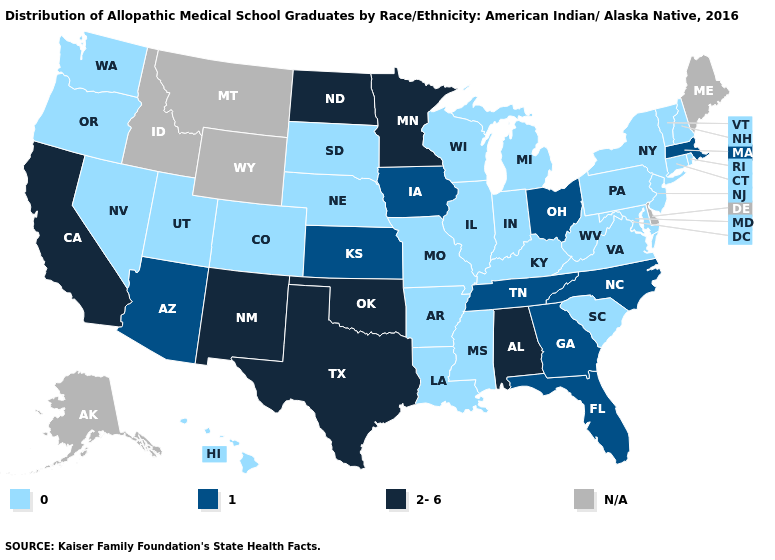Which states hav the highest value in the South?
Be succinct. Alabama, Oklahoma, Texas. What is the highest value in states that border Texas?
Quick response, please. 2-6. What is the value of Maryland?
Concise answer only. 0. Does Nebraska have the lowest value in the MidWest?
Short answer required. Yes. Among the states that border Texas , does Arkansas have the lowest value?
Concise answer only. Yes. What is the highest value in the South ?
Give a very brief answer. 2-6. What is the lowest value in the USA?
Write a very short answer. 0. Does the map have missing data?
Answer briefly. Yes. Name the states that have a value in the range N/A?
Answer briefly. Alaska, Delaware, Idaho, Maine, Montana, Wyoming. Does Massachusetts have the lowest value in the Northeast?
Quick response, please. No. Among the states that border Oklahoma , which have the highest value?
Quick response, please. New Mexico, Texas. Which states have the lowest value in the USA?
Keep it brief. Arkansas, Colorado, Connecticut, Hawaii, Illinois, Indiana, Kentucky, Louisiana, Maryland, Michigan, Mississippi, Missouri, Nebraska, Nevada, New Hampshire, New Jersey, New York, Oregon, Pennsylvania, Rhode Island, South Carolina, South Dakota, Utah, Vermont, Virginia, Washington, West Virginia, Wisconsin. What is the lowest value in states that border Kentucky?
Give a very brief answer. 0. 